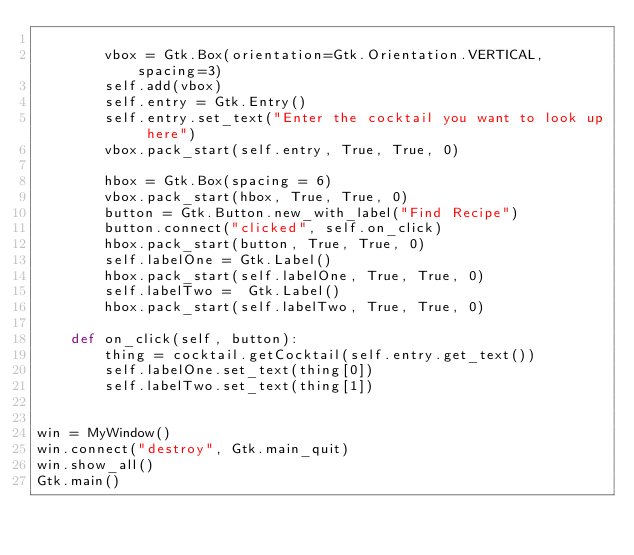<code> <loc_0><loc_0><loc_500><loc_500><_Python_>
        vbox = Gtk.Box(orientation=Gtk.Orientation.VERTICAL, spacing=3)
        self.add(vbox)
        self.entry = Gtk.Entry()
        self.entry.set_text("Enter the cocktail you want to look up here")
        vbox.pack_start(self.entry, True, True, 0)

        hbox = Gtk.Box(spacing = 6)
        vbox.pack_start(hbox, True, True, 0)
        button = Gtk.Button.new_with_label("Find Recipe")
        button.connect("clicked", self.on_click)
        hbox.pack_start(button, True, True, 0)
        self.labelOne = Gtk.Label()
        hbox.pack_start(self.labelOne, True, True, 0)
        self.labelTwo =  Gtk.Label()
        hbox.pack_start(self.labelTwo, True, True, 0)

    def on_click(self, button):
        thing = cocktail.getCocktail(self.entry.get_text())
        self.labelOne.set_text(thing[0])
        self.labelTwo.set_text(thing[1])


win = MyWindow()
win.connect("destroy", Gtk.main_quit)
win.show_all()
Gtk.main()

</code> 